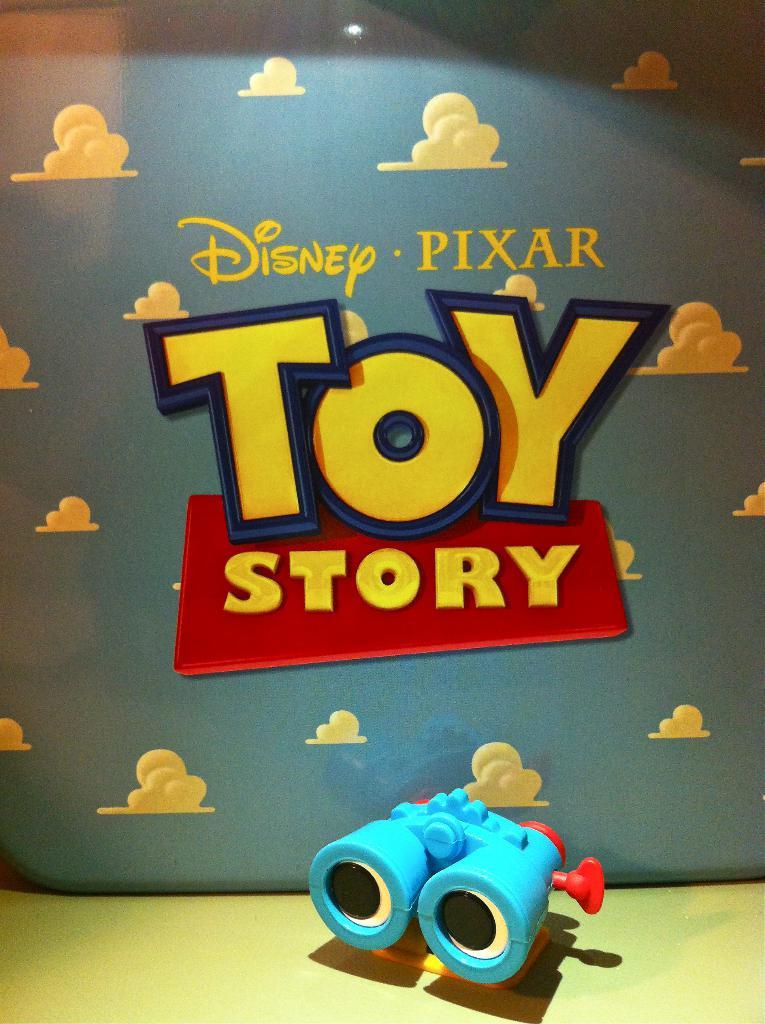What is the title of this movie?
Offer a terse response. Toy story. What company made this movie?
Make the answer very short. Disney pixar. 